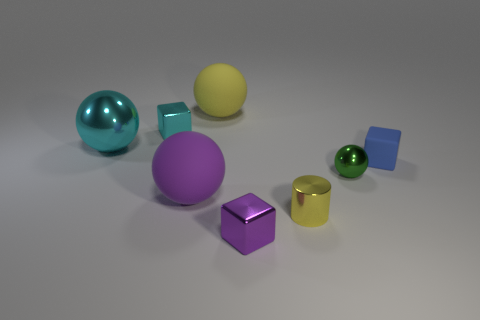What materials do the objects in the image look like they're made of? The objects evoke the appearance of being made from different kinds of polished metals and perhaps some reflective plastic, given their varying degrees of shininess and reflections. 